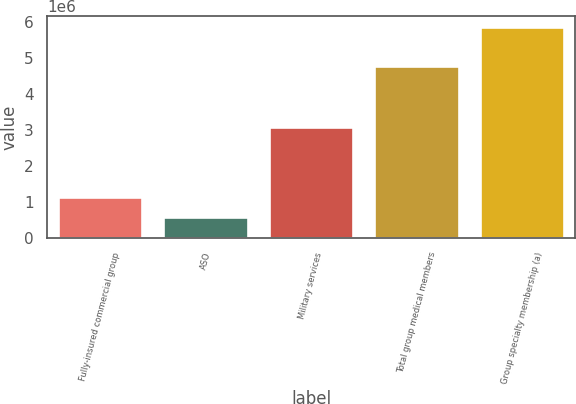Convert chart to OTSL. <chart><loc_0><loc_0><loc_500><loc_500><bar_chart><fcel>Fully-insured commercial group<fcel>ASO<fcel>Military services<fcel>Total group medical members<fcel>Group specialty membership (a)<nl><fcel>1.136e+06<fcel>573200<fcel>3.0841e+06<fcel>4.7933e+06<fcel>5.8731e+06<nl></chart> 